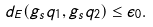<formula> <loc_0><loc_0><loc_500><loc_500>d _ { E } ( g _ { s } q _ { 1 } , g _ { s } q _ { 2 } ) \leq \epsilon _ { 0 } .</formula> 